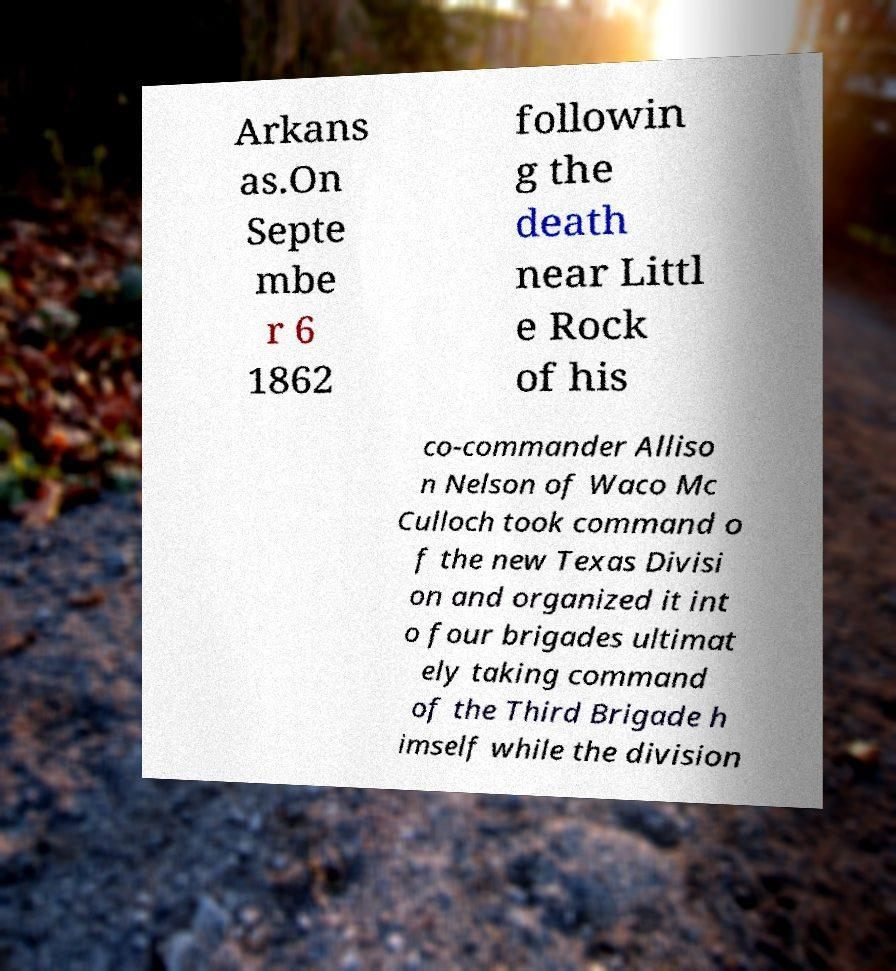There's text embedded in this image that I need extracted. Can you transcribe it verbatim? Arkans as.On Septe mbe r 6 1862 followin g the death near Littl e Rock of his co-commander Alliso n Nelson of Waco Mc Culloch took command o f the new Texas Divisi on and organized it int o four brigades ultimat ely taking command of the Third Brigade h imself while the division 